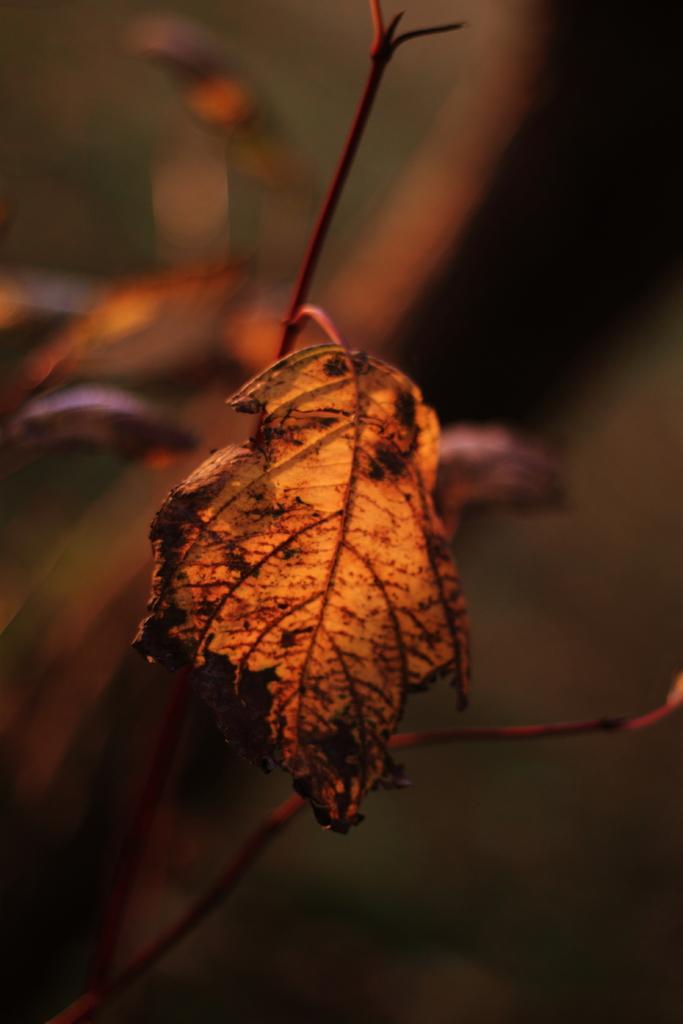Describe this image in one or two sentences. It is an edited image in which we can see there is a leaf in the middle. In the background it is blur. 